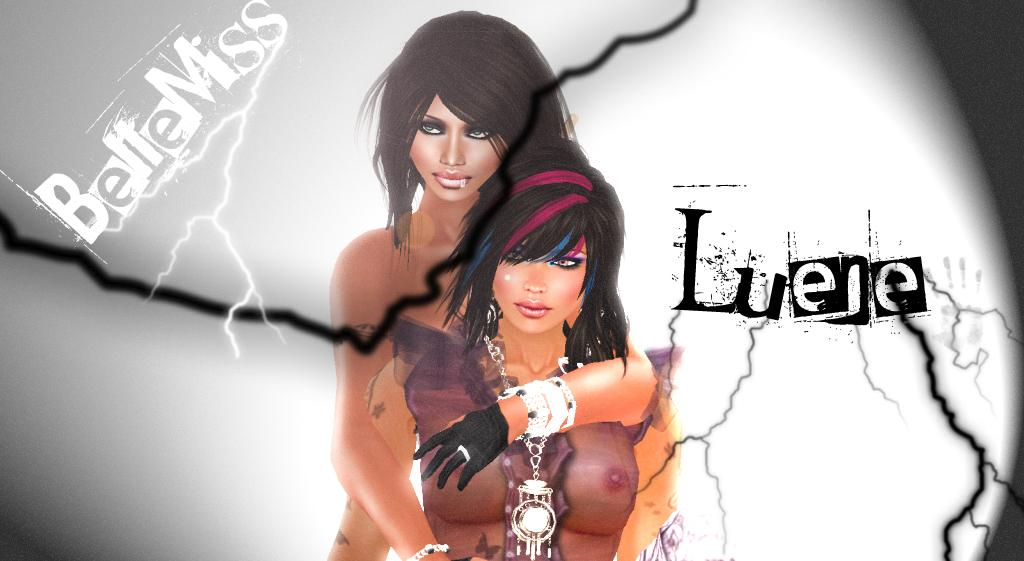What type of image is shown in the picture? There is an animated image of two women in the picture. Are there any words or phrases written on the image? Yes, there is text written on the image. What weather condition is depicted in the image? There is a thunder depicted in the image. What color is the surface behind the image? There is a white surface in the backdrop of the image. What type of curtain is hanging in front of the animated image? There is no curtain present in the image; it features an animated image of two women with text, thunder, and a white surface in the backdrop. 